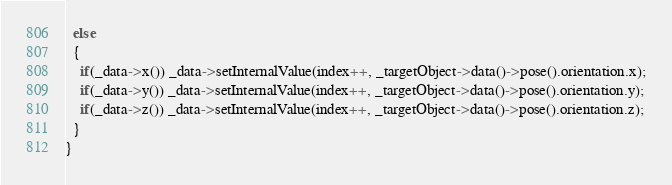<code> <loc_0><loc_0><loc_500><loc_500><_C++_>  else
  {
    if(_data->x()) _data->setInternalValue(index++, _targetObject->data()->pose().orientation.x);
    if(_data->y()) _data->setInternalValue(index++, _targetObject->data()->pose().orientation.y);
    if(_data->z()) _data->setInternalValue(index++, _targetObject->data()->pose().orientation.z);
  }
}


</code> 